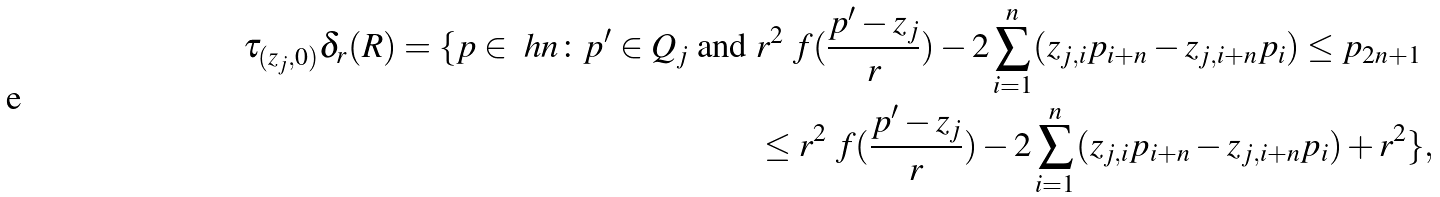<formula> <loc_0><loc_0><loc_500><loc_500>\tau _ { ( z _ { j } , 0 ) } \delta _ { r } ( R ) = \{ p \in \ h n \colon p ^ { \prime } \in Q _ { j } \text { and } & r ^ { 2 } \ f ( \frac { p ^ { \prime } - z _ { j } } { r } ) - 2 \sum _ { i = 1 } ^ { n } ( z _ { j , i } p _ { i + n } - z _ { j , i + n } p _ { i } ) \leq p _ { 2 n + 1 } \\ & \leq r ^ { 2 } \ f ( \frac { p ^ { \prime } - z _ { j } } { r } ) - 2 \sum _ { i = 1 } ^ { n } ( z _ { j , i } p _ { i + n } - z _ { j , i + n } p _ { i } ) + r ^ { 2 } \} ,</formula> 